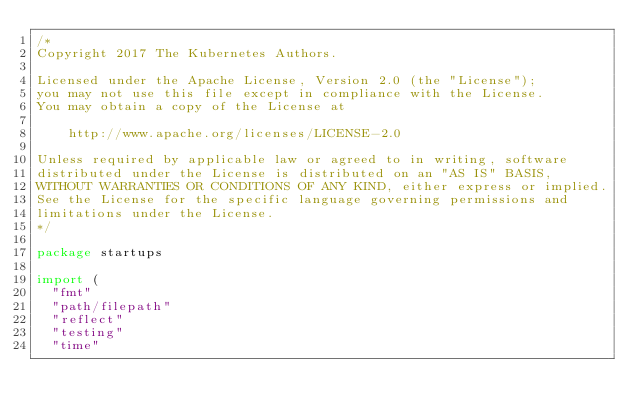<code> <loc_0><loc_0><loc_500><loc_500><_Go_>/*
Copyright 2017 The Kubernetes Authors.

Licensed under the Apache License, Version 2.0 (the "License");
you may not use this file except in compliance with the License.
You may obtain a copy of the License at

    http://www.apache.org/licenses/LICENSE-2.0

Unless required by applicable law or agreed to in writing, software
distributed under the License is distributed on an "AS IS" BASIS,
WITHOUT WARRANTIES OR CONDITIONS OF ANY KIND, either express or implied.
See the License for the specific language governing permissions and
limitations under the License.
*/

package startups

import (
	"fmt"
	"path/filepath"
	"reflect"
	"testing"
	"time"
</code> 